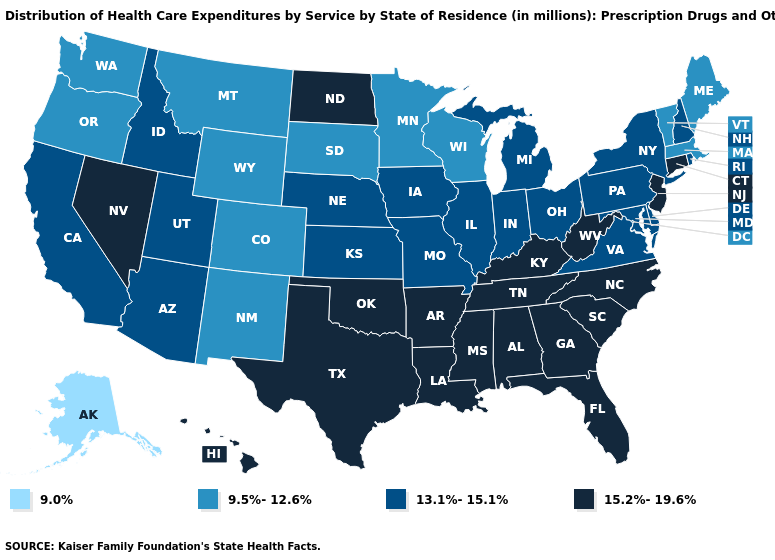What is the highest value in the South ?
Short answer required. 15.2%-19.6%. What is the value of Tennessee?
Short answer required. 15.2%-19.6%. Name the states that have a value in the range 15.2%-19.6%?
Answer briefly. Alabama, Arkansas, Connecticut, Florida, Georgia, Hawaii, Kentucky, Louisiana, Mississippi, Nevada, New Jersey, North Carolina, North Dakota, Oklahoma, South Carolina, Tennessee, Texas, West Virginia. Does Maryland have the lowest value in the South?
Keep it brief. Yes. Name the states that have a value in the range 15.2%-19.6%?
Write a very short answer. Alabama, Arkansas, Connecticut, Florida, Georgia, Hawaii, Kentucky, Louisiana, Mississippi, Nevada, New Jersey, North Carolina, North Dakota, Oklahoma, South Carolina, Tennessee, Texas, West Virginia. Does Alaska have the lowest value in the USA?
Give a very brief answer. Yes. Among the states that border Tennessee , which have the highest value?
Short answer required. Alabama, Arkansas, Georgia, Kentucky, Mississippi, North Carolina. What is the value of North Dakota?
Write a very short answer. 15.2%-19.6%. What is the value of West Virginia?
Be succinct. 15.2%-19.6%. What is the lowest value in states that border Maine?
Answer briefly. 13.1%-15.1%. Which states hav the highest value in the MidWest?
Keep it brief. North Dakota. Does Pennsylvania have a lower value than North Carolina?
Quick response, please. Yes. What is the highest value in states that border Indiana?
Give a very brief answer. 15.2%-19.6%. Does Maine have the lowest value in the Northeast?
Be succinct. Yes. Name the states that have a value in the range 9.5%-12.6%?
Keep it brief. Colorado, Maine, Massachusetts, Minnesota, Montana, New Mexico, Oregon, South Dakota, Vermont, Washington, Wisconsin, Wyoming. 